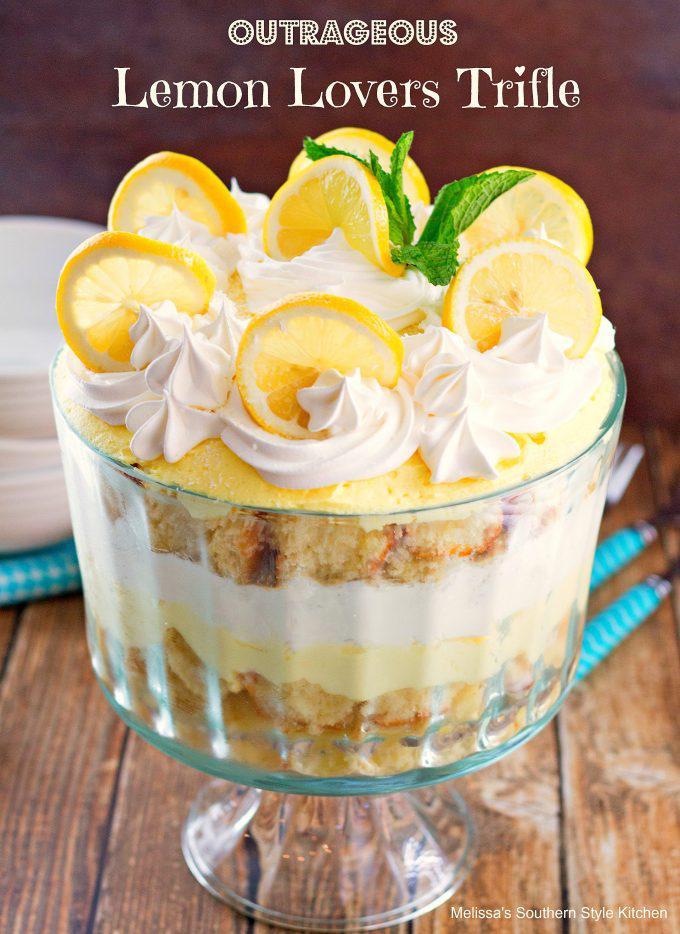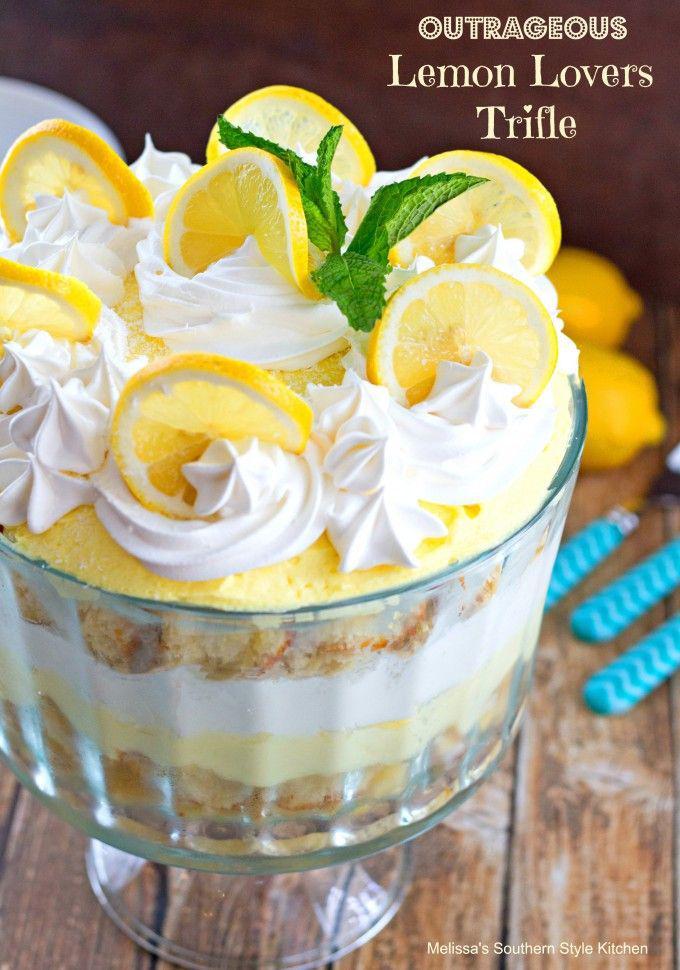The first image is the image on the left, the second image is the image on the right. For the images shown, is this caption "Part of some utensils are visible." true? Answer yes or no. Yes. The first image is the image on the left, the second image is the image on the right. For the images displayed, is the sentence "Berries top a trifle in one image." factually correct? Answer yes or no. No. 